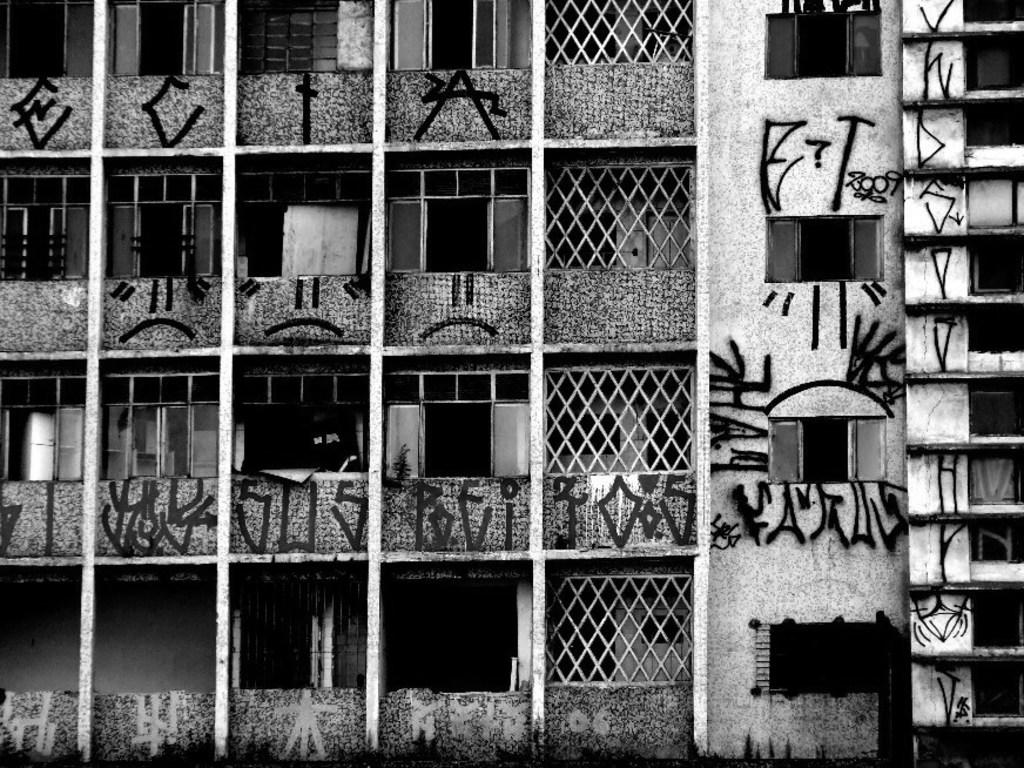What type of structures can be seen in the image? There are buildings in the image. What architectural features are visible on the buildings? There are windows and doors visible on the buildings. What type of barrier is present in the image? There is a fence in the image. What type of artwork can be seen in the image? There are paintings on a wall in the image. Can you describe the lighting conditions in the image? The image may have been taken in the evening, suggesting that the lighting is dimmer. How much dust can be seen on the road in the image? There is no road present in the image, so it is not possible to determine the amount of dust on it. 